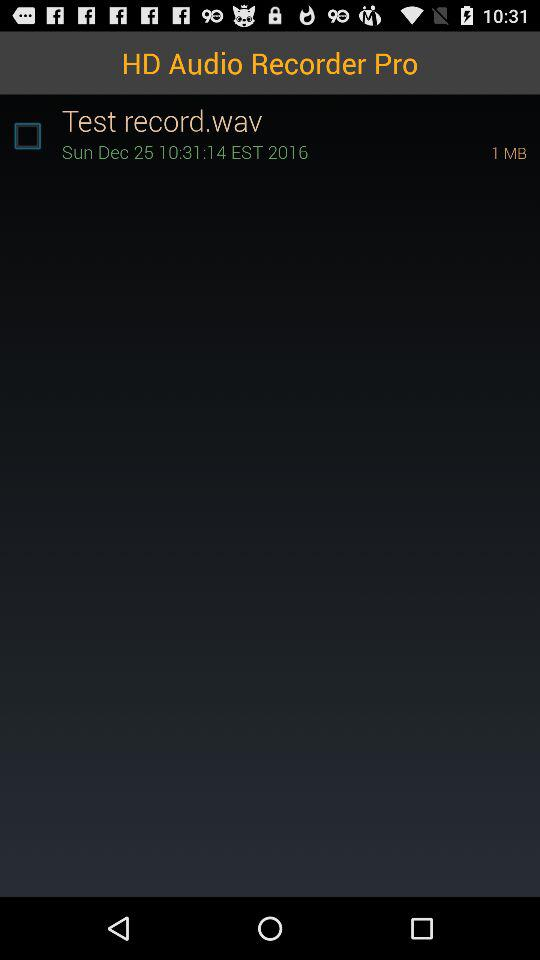What is the file size of the recording?
Answer the question using a single word or phrase. 1 MB 